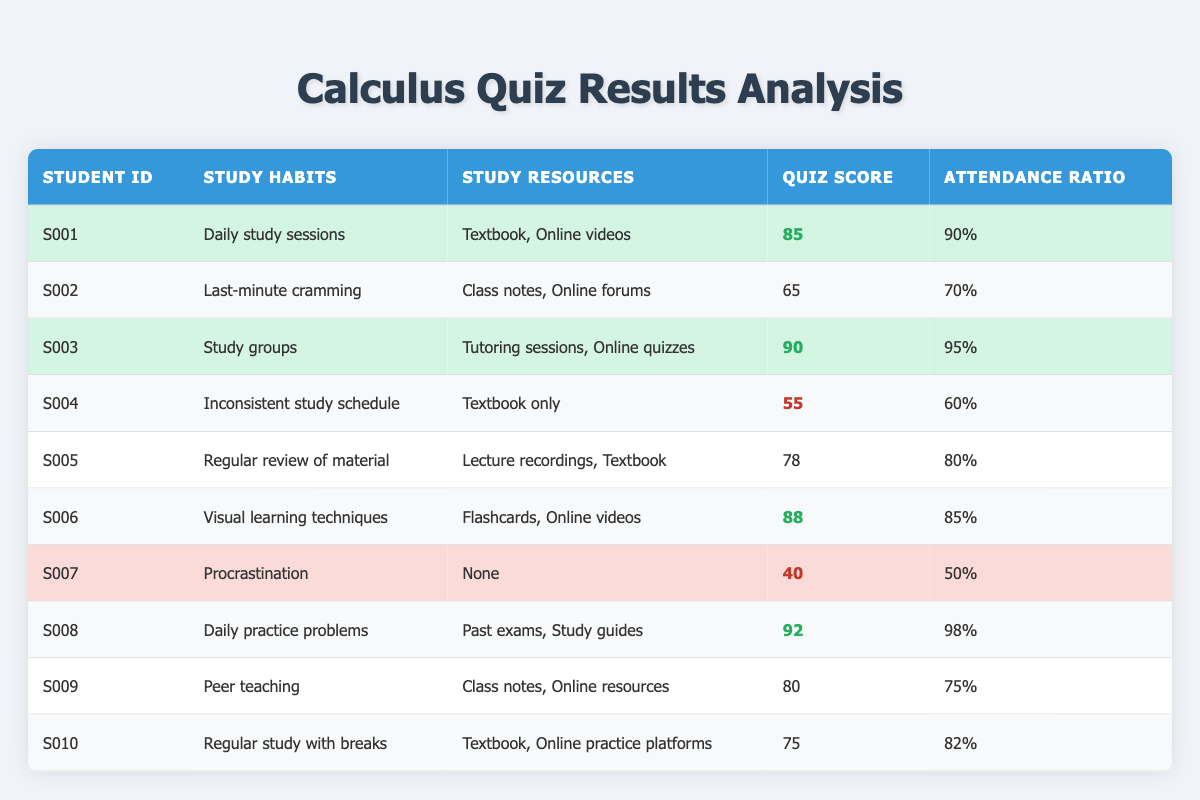What is the quiz score of student S006? The table shows that student S006 has a quiz score listed as 88.
Answer: 88 Which student has the highest attendance ratio? Looking through the attendance ratio column, S008 has the highest attendance ratio of 98%.
Answer: S008 What are the study resources utilized by student S005? The table lists the study resources for S005 as Lecture recordings and Textbook.
Answer: Lecture recordings, Textbook Is it true that all students who scored above 80 had an attendance ratio above 80%? Checking the scores and attendance ratios: S003 (90, 95%), S006 (88, 85%), S008 (92, 98%), and S009 (80, 75%). S009, who scored 80, has a 75% attendance, which is below 80%. Therefore, the statement is false.
Answer: No What is the average quiz score of students who utilized "Online videos" as a study resource? The relevant students are S001 (85), S003 (90), S006 (88), and S008 (92). Their total score is 85 + 90 + 88 + 92 = 355. There are 4 students, so the average is 355 / 4 = 88.75.
Answer: 88.75 How many students have study habits categorized as "Inconsistent study schedule" or “Procrastination”? The table shows that S004 (Inconsistent study schedule) and S007 (Procrastination) fit this category. Thus, there are 2 students in total.
Answer: 2 Which study habit is associated with the lowest quiz score? The lowest quiz score in the table is 40, associated with student S007, who has "Procrastination" as their study habit.
Answer: Procrastination What is the difference between the highest and lowest quiz scores? The highest quiz score is 92 (S008), and the lowest is 40 (S007). The difference is 92 - 40 = 52.
Answer: 52 Which student scored below 60 and what were their study habits? Only S004 scored below 60 with a quiz score of 55. Their study habit is "Inconsistent study schedule".
Answer: S004, Inconsistent study schedule 